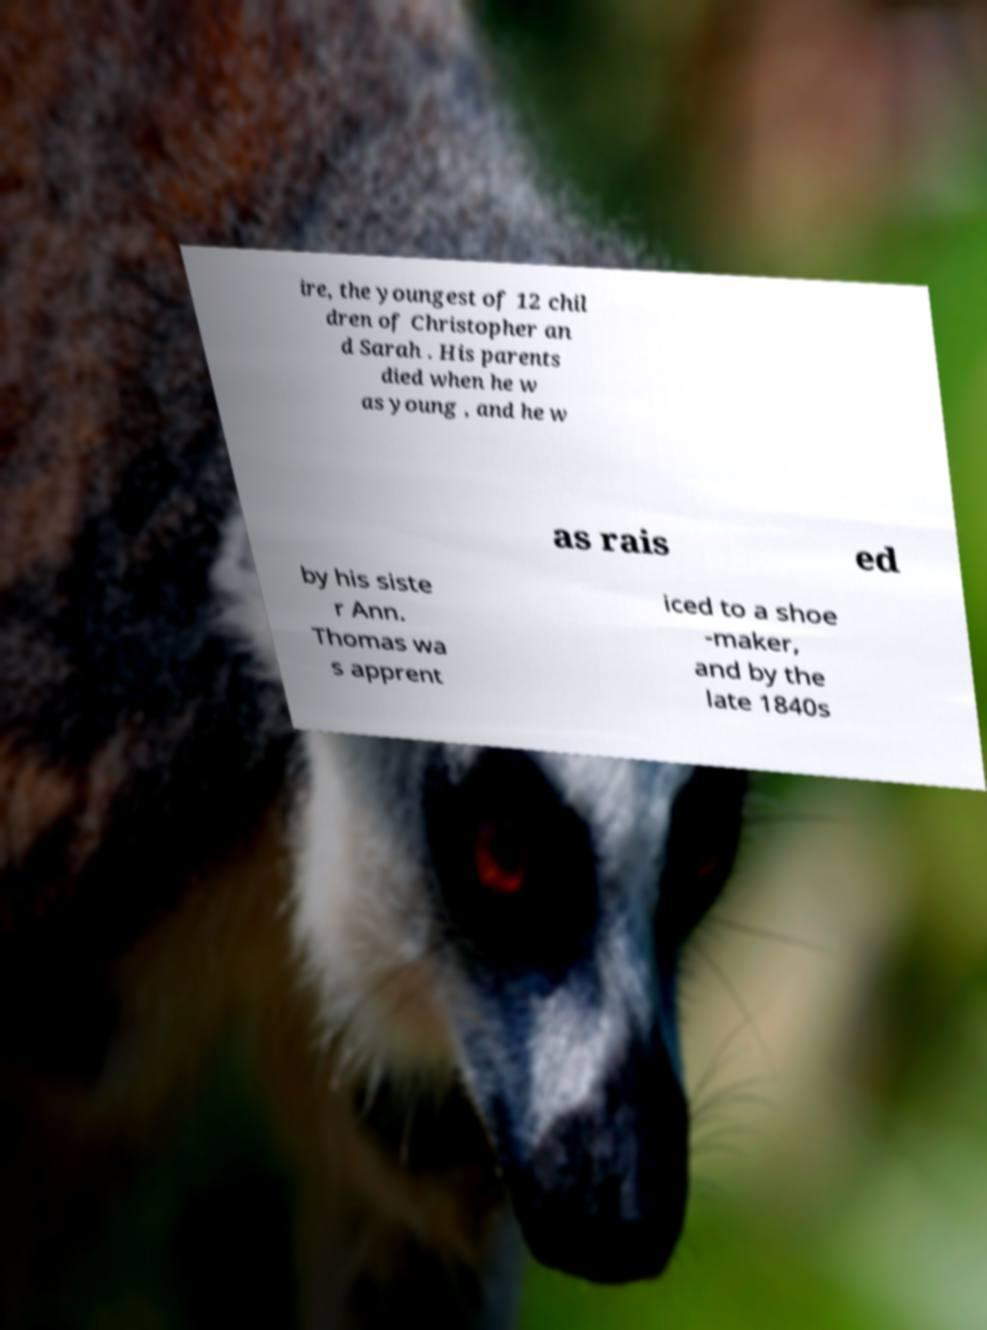What messages or text are displayed in this image? I need them in a readable, typed format. ire, the youngest of 12 chil dren of Christopher an d Sarah . His parents died when he w as young , and he w as rais ed by his siste r Ann. Thomas wa s apprent iced to a shoe -maker, and by the late 1840s 